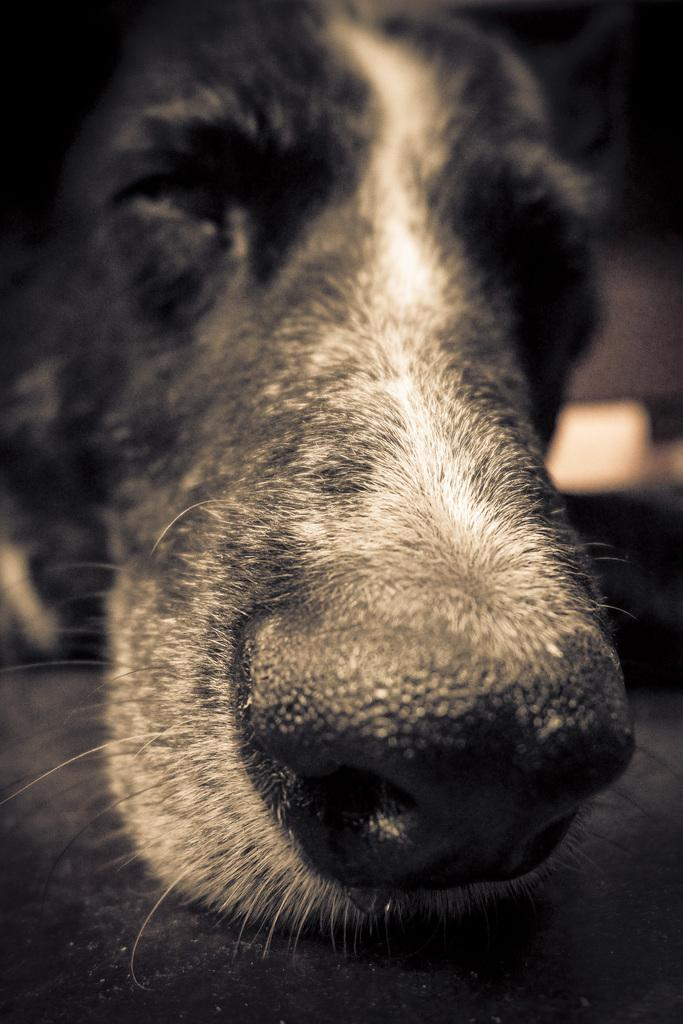What is the main subject of the image? The main subject of the image is a dog's face. Can you describe the dog's face in the image? The image only shows the dog's face, so it is not possible to provide a detailed description. What type of vessel is the dog fighting in the image? There is no vessel or fighting depicted in the image; it only shows a dog's face. 